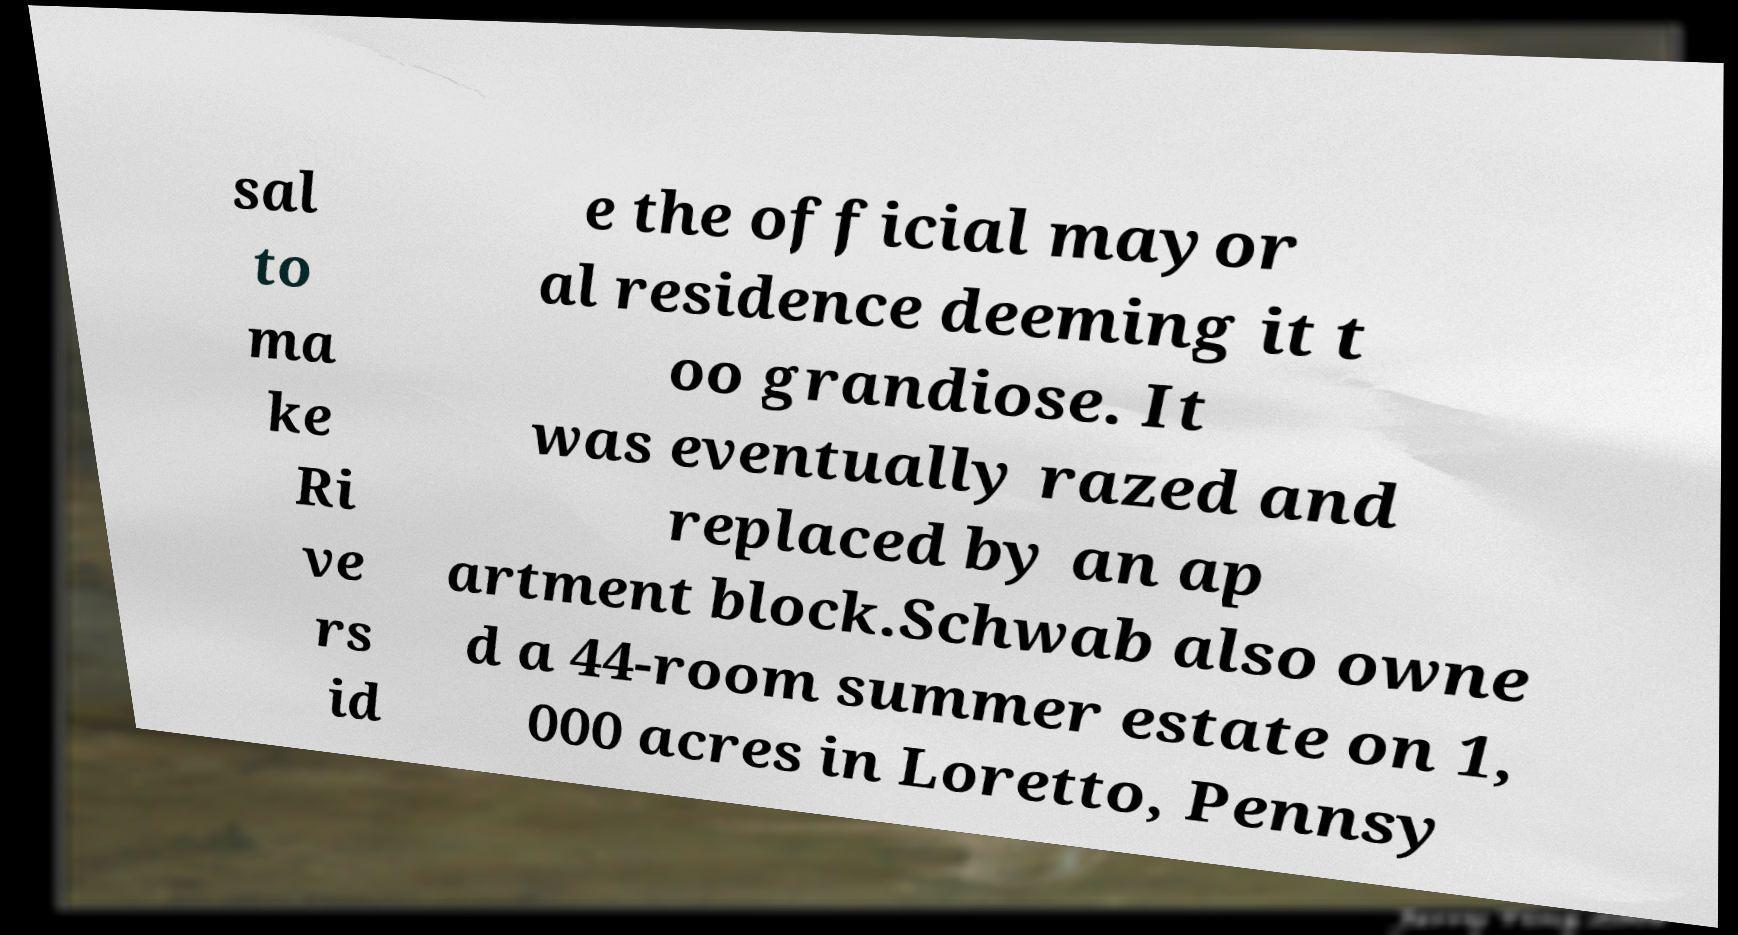I need the written content from this picture converted into text. Can you do that? sal to ma ke Ri ve rs id e the official mayor al residence deeming it t oo grandiose. It was eventually razed and replaced by an ap artment block.Schwab also owne d a 44-room summer estate on 1, 000 acres in Loretto, Pennsy 